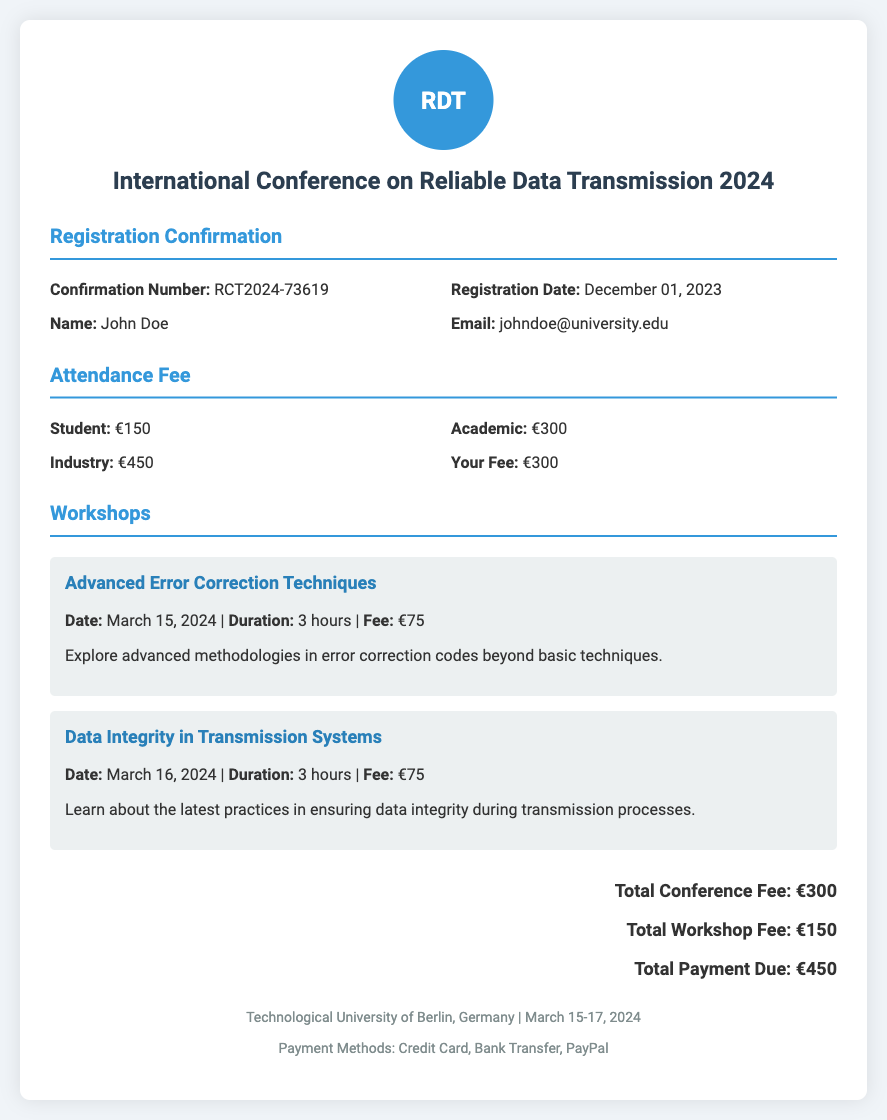What is the confirmation number? The confirmation number is a unique identifier for the registration provided in the document.
Answer: RCT2024-73619 What is the registration date? The registration date indicates when the participant registered for the conference.
Answer: December 01, 2023 What is the fee for a Student attending the conference? This fee is specified in the attendance fee section of the document.
Answer: €150 What is the total workshop fee? The total workshop fee is the sum of the fees for all workshops listed in the document.
Answer: €150 What is the fee for the "Advanced Error Correction Techniques" workshop? This fee is mentioned in the workshop details specifically for that workshop.
Answer: €75 How many workshops are listed in the document? This reflects the number of unique workshop options available for attendees as provided in the document.
Answer: 2 What is the duration of each workshop? This details how long each workshop will be held, as given in the workshop descriptions.
Answer: 3 hours What is the total payment due? The total payment due combines the conference fee and workshop fees.
Answer: €450 Where is the conference being held? The location of the conference is stated in the footer of the document.
Answer: Technological University of Berlin, Germany 